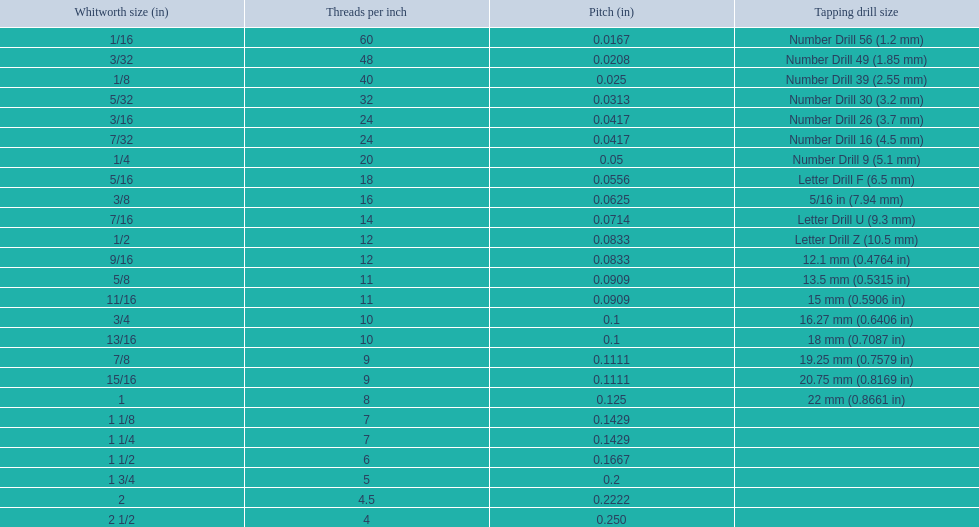What are the standard whitworth sizes in inches? 1/16, 3/32, 1/8, 5/32, 3/16, 7/32, 1/4, 5/16, 3/8, 7/16, 1/2, 9/16, 5/8, 11/16, 3/4, 13/16, 7/8, 15/16, 1, 1 1/8, 1 1/4, 1 1/2, 1 3/4, 2, 2 1/2. How many threads per inch does the 3/16 size have? 24. Which size (in inches) has the same number of threads? 7/32. 